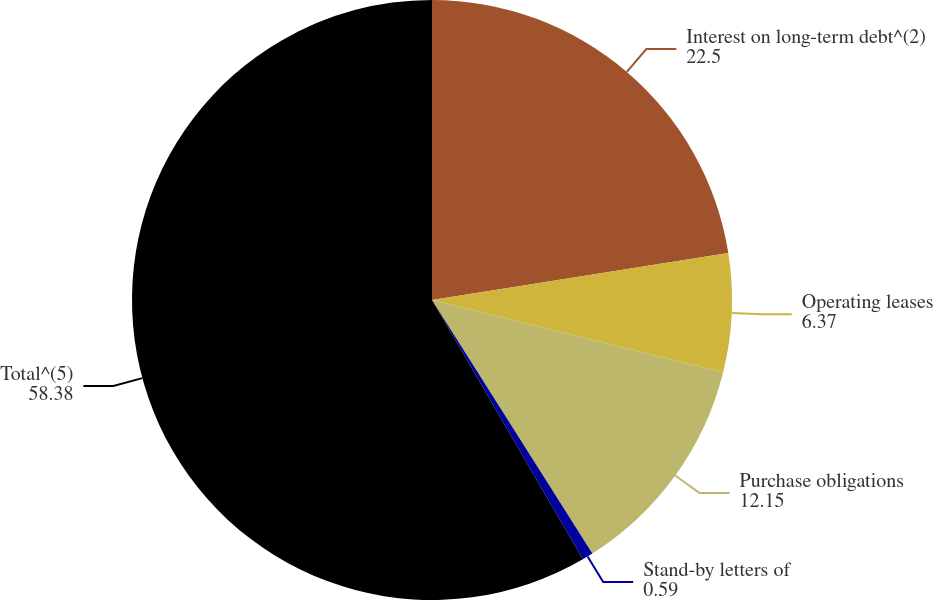Convert chart to OTSL. <chart><loc_0><loc_0><loc_500><loc_500><pie_chart><fcel>Interest on long-term debt^(2)<fcel>Operating leases<fcel>Purchase obligations<fcel>Stand-by letters of<fcel>Total^(5)<nl><fcel>22.5%<fcel>6.37%<fcel>12.15%<fcel>0.59%<fcel>58.38%<nl></chart> 